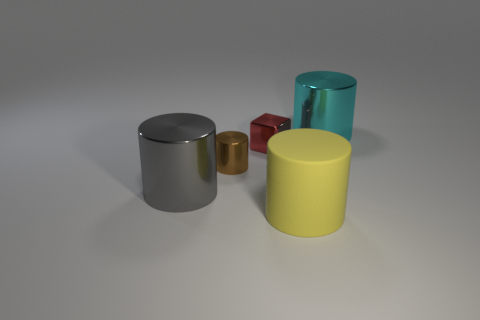There is a large thing in front of the big metallic cylinder that is in front of the big shiny thing behind the big gray cylinder; what color is it?
Offer a very short reply. Yellow. There is a large shiny cylinder that is left of the big cyan cylinder; what color is it?
Give a very brief answer. Gray. What color is the metal block that is the same size as the brown object?
Ensure brevity in your answer.  Red. Is the size of the yellow thing the same as the brown thing?
Provide a short and direct response. No. There is a small red cube; how many yellow cylinders are behind it?
Make the answer very short. 0. How many objects are yellow matte cylinders to the right of the tiny red object or matte things?
Offer a terse response. 1. Are there more cylinders to the right of the big yellow object than cyan metallic cylinders that are in front of the small metal block?
Provide a succinct answer. Yes. There is a rubber cylinder; is its size the same as the brown object that is to the left of the red cube?
Provide a short and direct response. No. How many cylinders are tiny things or red objects?
Ensure brevity in your answer.  1. What size is the cyan thing that is made of the same material as the big gray object?
Offer a very short reply. Large. 